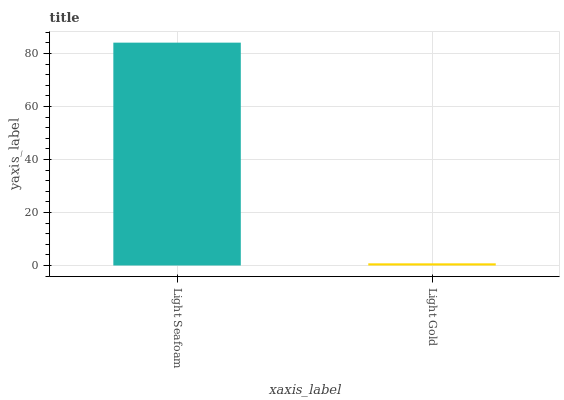Is Light Gold the minimum?
Answer yes or no. Yes. Is Light Seafoam the maximum?
Answer yes or no. Yes. Is Light Gold the maximum?
Answer yes or no. No. Is Light Seafoam greater than Light Gold?
Answer yes or no. Yes. Is Light Gold less than Light Seafoam?
Answer yes or no. Yes. Is Light Gold greater than Light Seafoam?
Answer yes or no. No. Is Light Seafoam less than Light Gold?
Answer yes or no. No. Is Light Seafoam the high median?
Answer yes or no. Yes. Is Light Gold the low median?
Answer yes or no. Yes. Is Light Gold the high median?
Answer yes or no. No. Is Light Seafoam the low median?
Answer yes or no. No. 